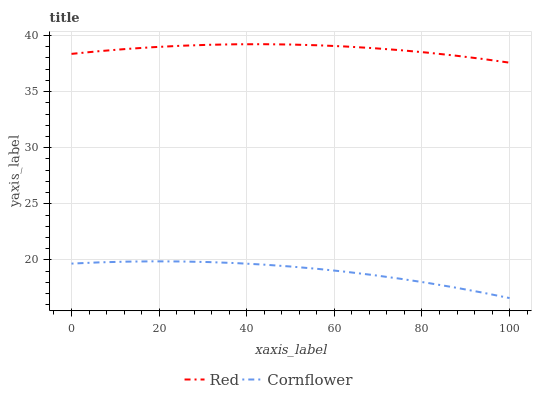Does Cornflower have the minimum area under the curve?
Answer yes or no. Yes. Does Red have the maximum area under the curve?
Answer yes or no. Yes. Does Red have the minimum area under the curve?
Answer yes or no. No. Is Red the smoothest?
Answer yes or no. Yes. Is Cornflower the roughest?
Answer yes or no. Yes. Is Red the roughest?
Answer yes or no. No. Does Cornflower have the lowest value?
Answer yes or no. Yes. Does Red have the lowest value?
Answer yes or no. No. Does Red have the highest value?
Answer yes or no. Yes. Is Cornflower less than Red?
Answer yes or no. Yes. Is Red greater than Cornflower?
Answer yes or no. Yes. Does Cornflower intersect Red?
Answer yes or no. No. 